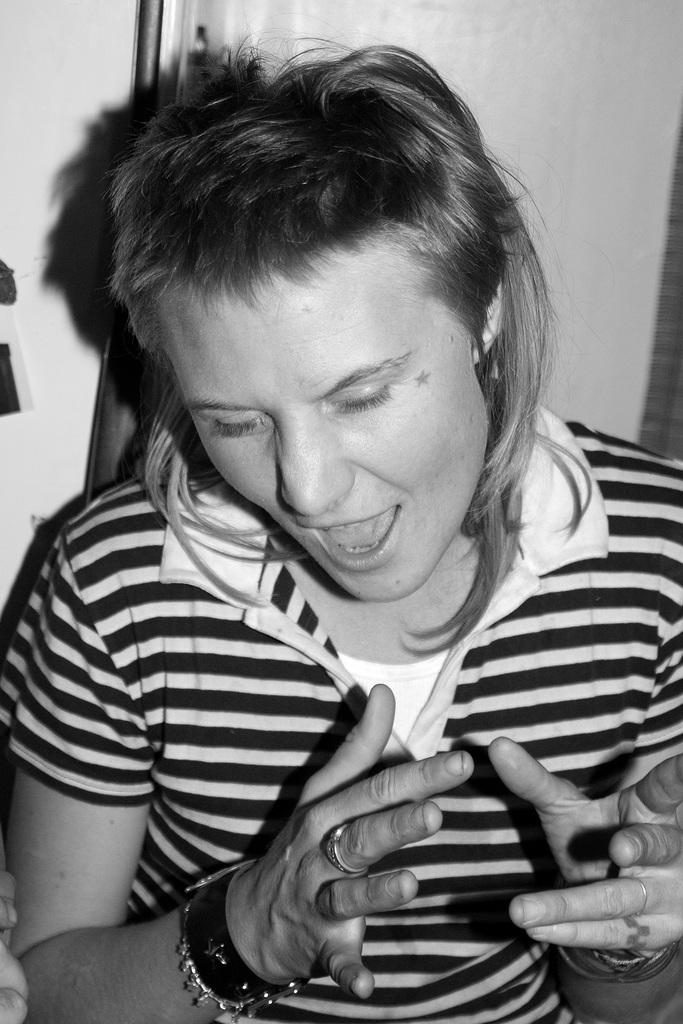What is the main subject in the foreground of the image? There is a person in the foreground of the image. What is the person wearing? The person is wearing a t-shirt. What is the person's posture in the image? The person appears to be standing. What can be seen in the background of the image? There is a wall and other objects visible in the background of the image. What type of steel is being used to cook the stew in the image? There is no stew or steel present in the image; it features a person standing in the foreground with a wall and other objects in the background. 